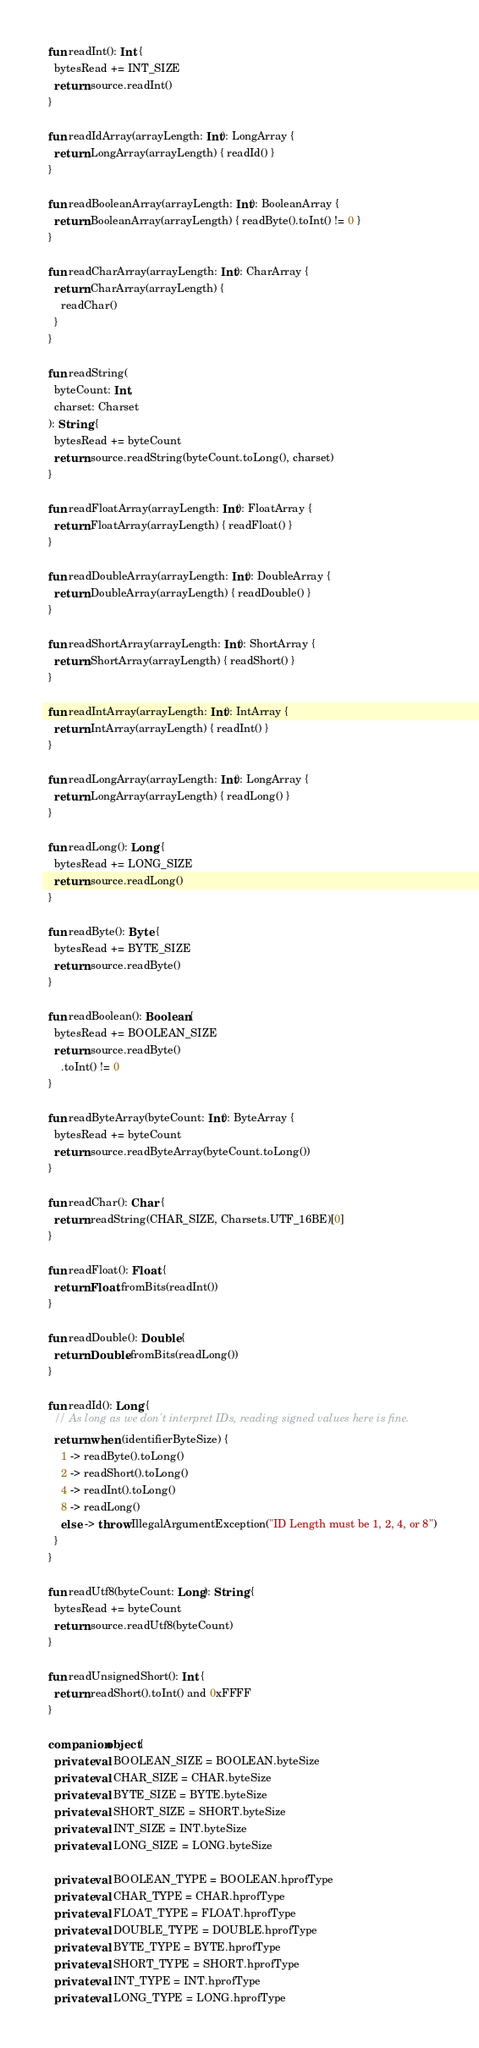<code> <loc_0><loc_0><loc_500><loc_500><_Kotlin_>  fun readInt(): Int {
    bytesRead += INT_SIZE
    return source.readInt()
  }

  fun readIdArray(arrayLength: Int): LongArray {
    return LongArray(arrayLength) { readId() }
  }

  fun readBooleanArray(arrayLength: Int): BooleanArray {
    return BooleanArray(arrayLength) { readByte().toInt() != 0 }
  }

  fun readCharArray(arrayLength: Int): CharArray {
    return CharArray(arrayLength) {
      readChar()
    }
  }

  fun readString(
    byteCount: Int,
    charset: Charset
  ): String {
    bytesRead += byteCount
    return source.readString(byteCount.toLong(), charset)
  }

  fun readFloatArray(arrayLength: Int): FloatArray {
    return FloatArray(arrayLength) { readFloat() }
  }

  fun readDoubleArray(arrayLength: Int): DoubleArray {
    return DoubleArray(arrayLength) { readDouble() }
  }

  fun readShortArray(arrayLength: Int): ShortArray {
    return ShortArray(arrayLength) { readShort() }
  }

  fun readIntArray(arrayLength: Int): IntArray {
    return IntArray(arrayLength) { readInt() }
  }

  fun readLongArray(arrayLength: Int): LongArray {
    return LongArray(arrayLength) { readLong() }
  }

  fun readLong(): Long {
    bytesRead += LONG_SIZE
    return source.readLong()
  }

  fun readByte(): Byte {
    bytesRead += BYTE_SIZE
    return source.readByte()
  }

  fun readBoolean(): Boolean {
    bytesRead += BOOLEAN_SIZE
    return source.readByte()
      .toInt() != 0
  }

  fun readByteArray(byteCount: Int): ByteArray {
    bytesRead += byteCount
    return source.readByteArray(byteCount.toLong())
  }

  fun readChar(): Char {
    return readString(CHAR_SIZE, Charsets.UTF_16BE)[0]
  }

  fun readFloat(): Float {
    return Float.fromBits(readInt())
  }

  fun readDouble(): Double {
    return Double.fromBits(readLong())
  }

  fun readId(): Long {
    // As long as we don't interpret IDs, reading signed values here is fine.
    return when (identifierByteSize) {
      1 -> readByte().toLong()
      2 -> readShort().toLong()
      4 -> readInt().toLong()
      8 -> readLong()
      else -> throw IllegalArgumentException("ID Length must be 1, 2, 4, or 8")
    }
  }

  fun readUtf8(byteCount: Long): String {
    bytesRead += byteCount
    return source.readUtf8(byteCount)
  }

  fun readUnsignedShort(): Int {
    return readShort().toInt() and 0xFFFF
  }

  companion object {
    private val BOOLEAN_SIZE = BOOLEAN.byteSize
    private val CHAR_SIZE = CHAR.byteSize
    private val BYTE_SIZE = BYTE.byteSize
    private val SHORT_SIZE = SHORT.byteSize
    private val INT_SIZE = INT.byteSize
    private val LONG_SIZE = LONG.byteSize

    private val BOOLEAN_TYPE = BOOLEAN.hprofType
    private val CHAR_TYPE = CHAR.hprofType
    private val FLOAT_TYPE = FLOAT.hprofType
    private val DOUBLE_TYPE = DOUBLE.hprofType
    private val BYTE_TYPE = BYTE.hprofType
    private val SHORT_TYPE = SHORT.hprofType
    private val INT_TYPE = INT.hprofType
    private val LONG_TYPE = LONG.hprofType
</code> 